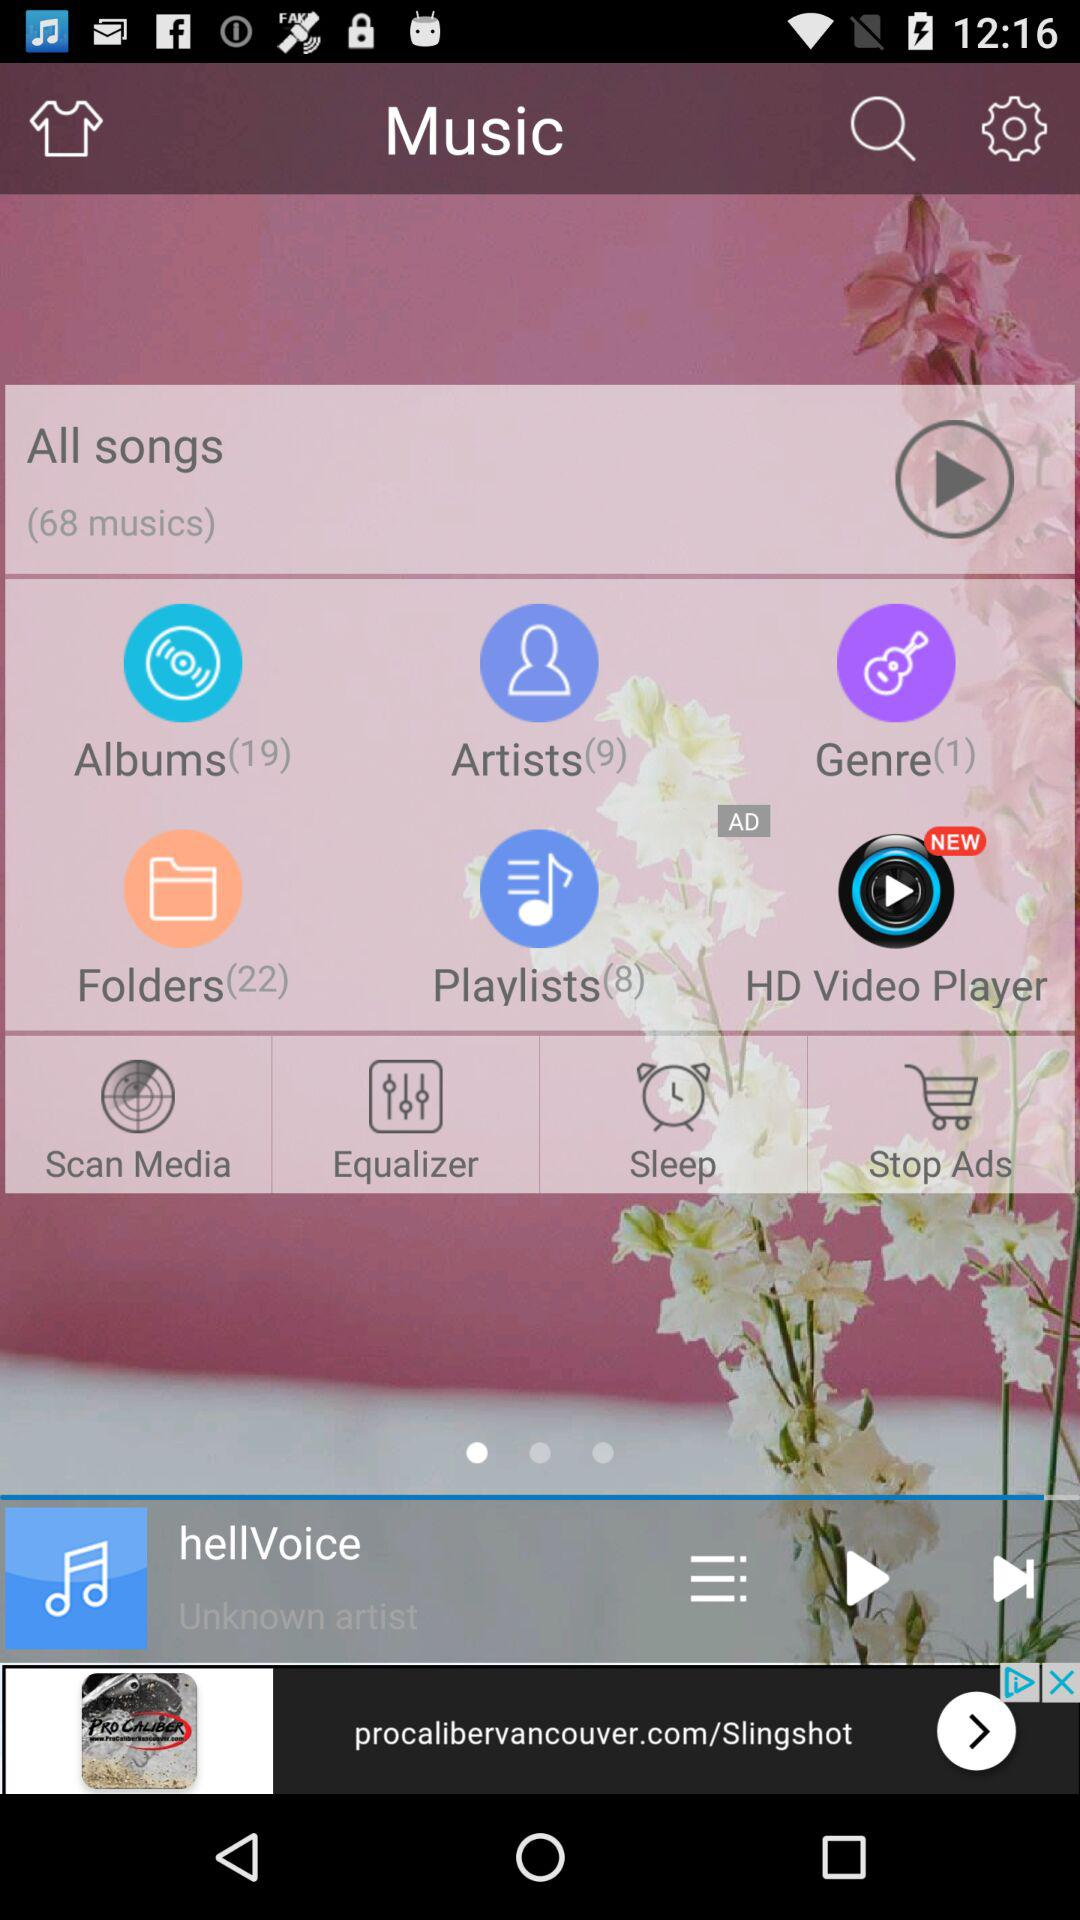How many songs are there in the playlists folder? There are 8 songs. 